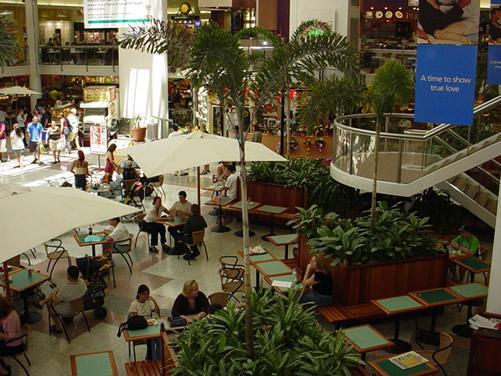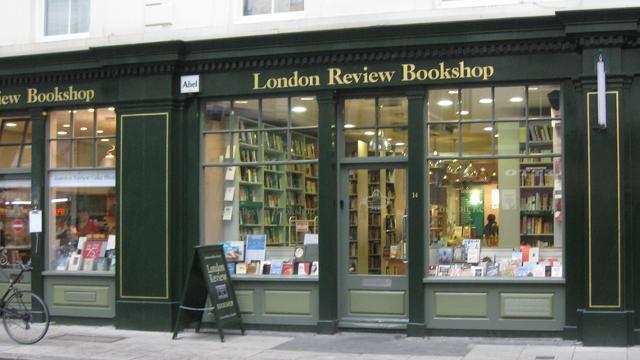The first image is the image on the left, the second image is the image on the right. Examine the images to the left and right. Is the description "In the image on the left, at least 8 people are sitting at tables in the food court." accurate? Answer yes or no. Yes. The first image is the image on the left, the second image is the image on the right. Given the left and right images, does the statement "At least one of the images includes a tree." hold true? Answer yes or no. Yes. 